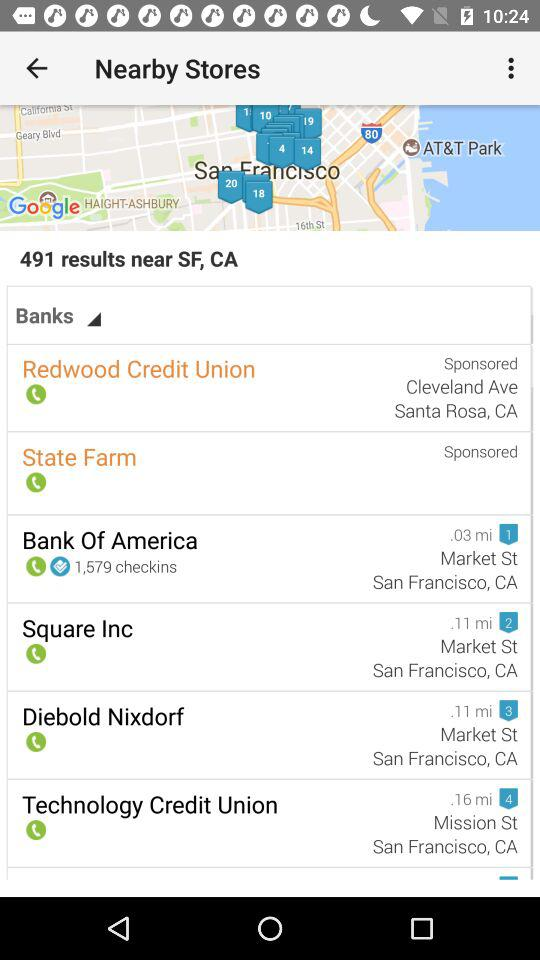How many results are shown for the search term Banks? The search results display a total of 491 results for the term 'Banks' in the vicinity of San Francisco, indicating a wide array of banking services or locations available in the area. 